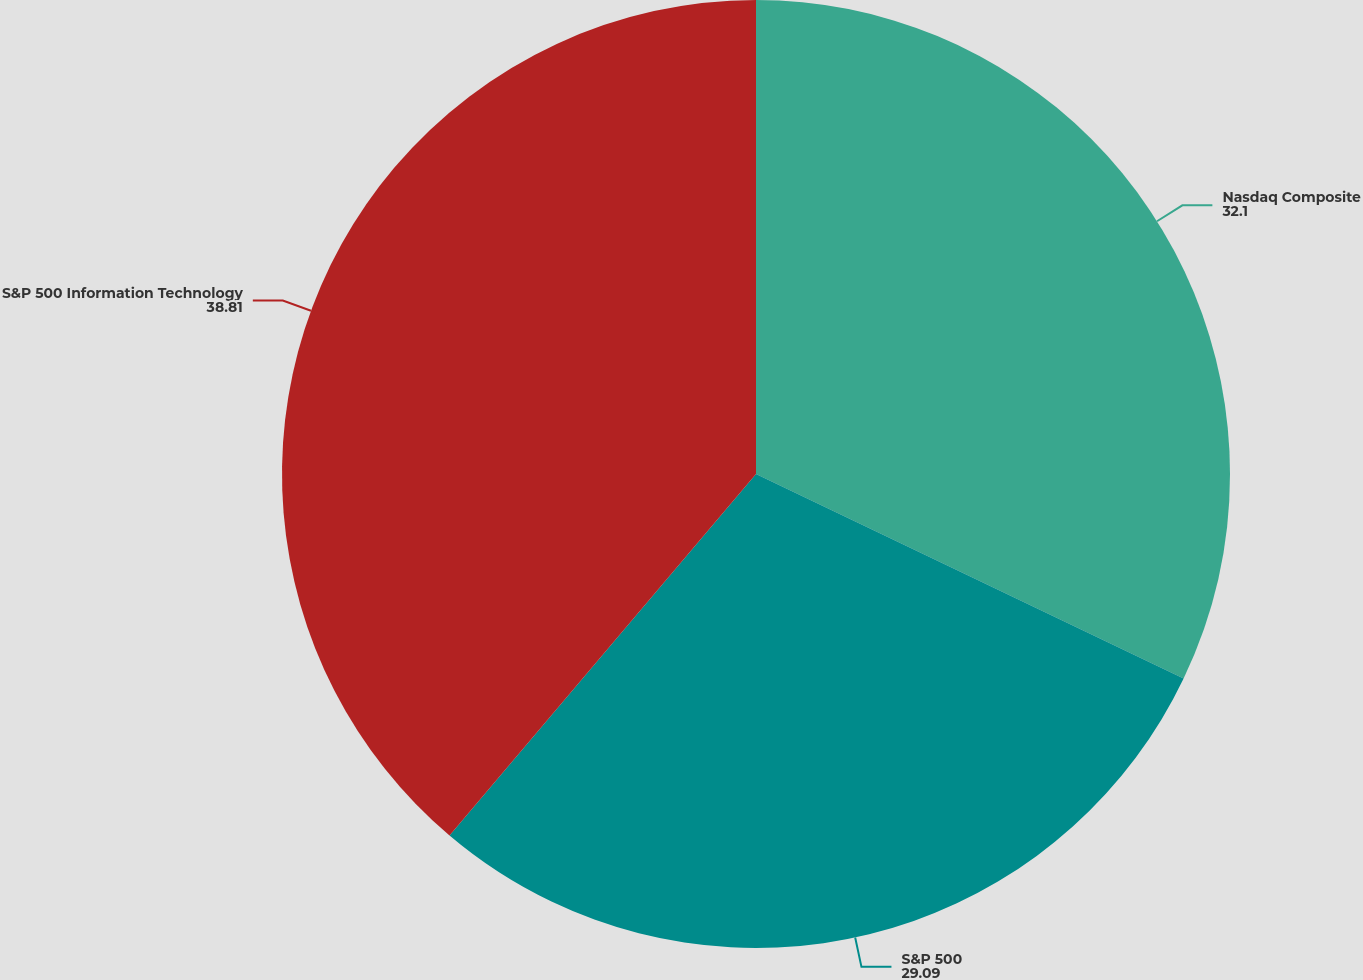Convert chart to OTSL. <chart><loc_0><loc_0><loc_500><loc_500><pie_chart><fcel>Nasdaq Composite<fcel>S&P 500<fcel>S&P 500 Information Technology<nl><fcel>32.1%<fcel>29.09%<fcel>38.81%<nl></chart> 